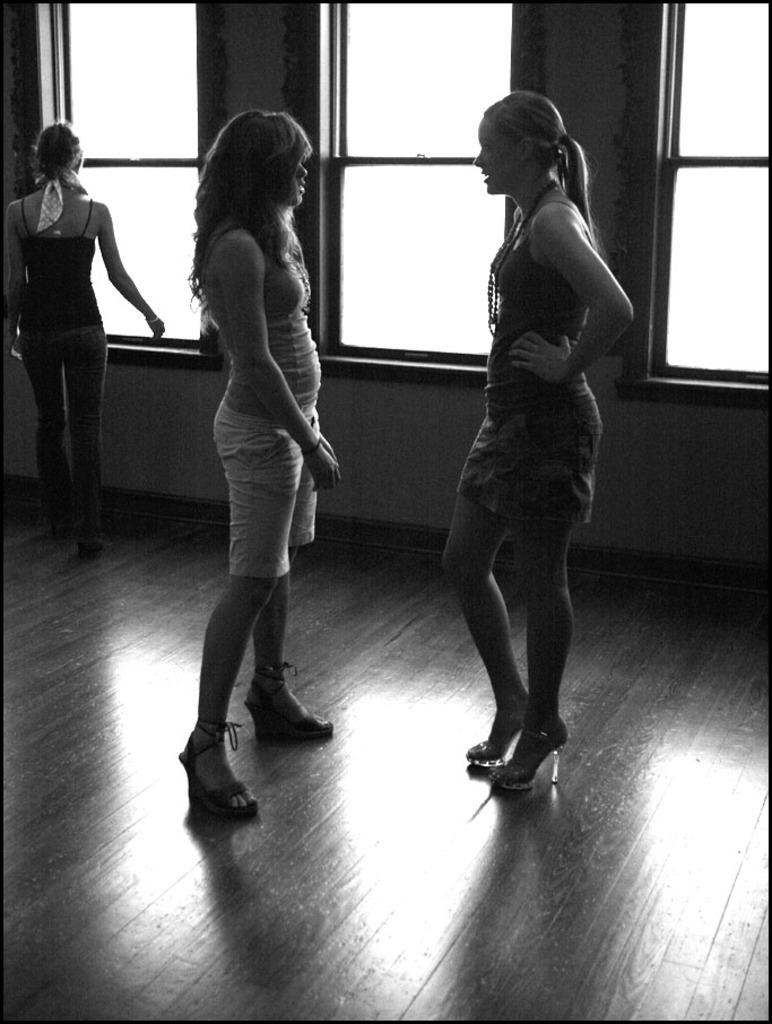How many girls are in the image? There are three girls in the image. Where are the girls located in the image? Two girls are in the center of the image, and another girl is on the left side of the image. What can be seen in the background of the image? There are windows in the background of the image. What type of structure can be seen in the background of the image? There is no specific structure mentioned in the image; only windows are visible in the background. Are there any animals from a zoo present in the image? There is no mention of any animals or a zoo in the image; it features three girls and windows in the background. 